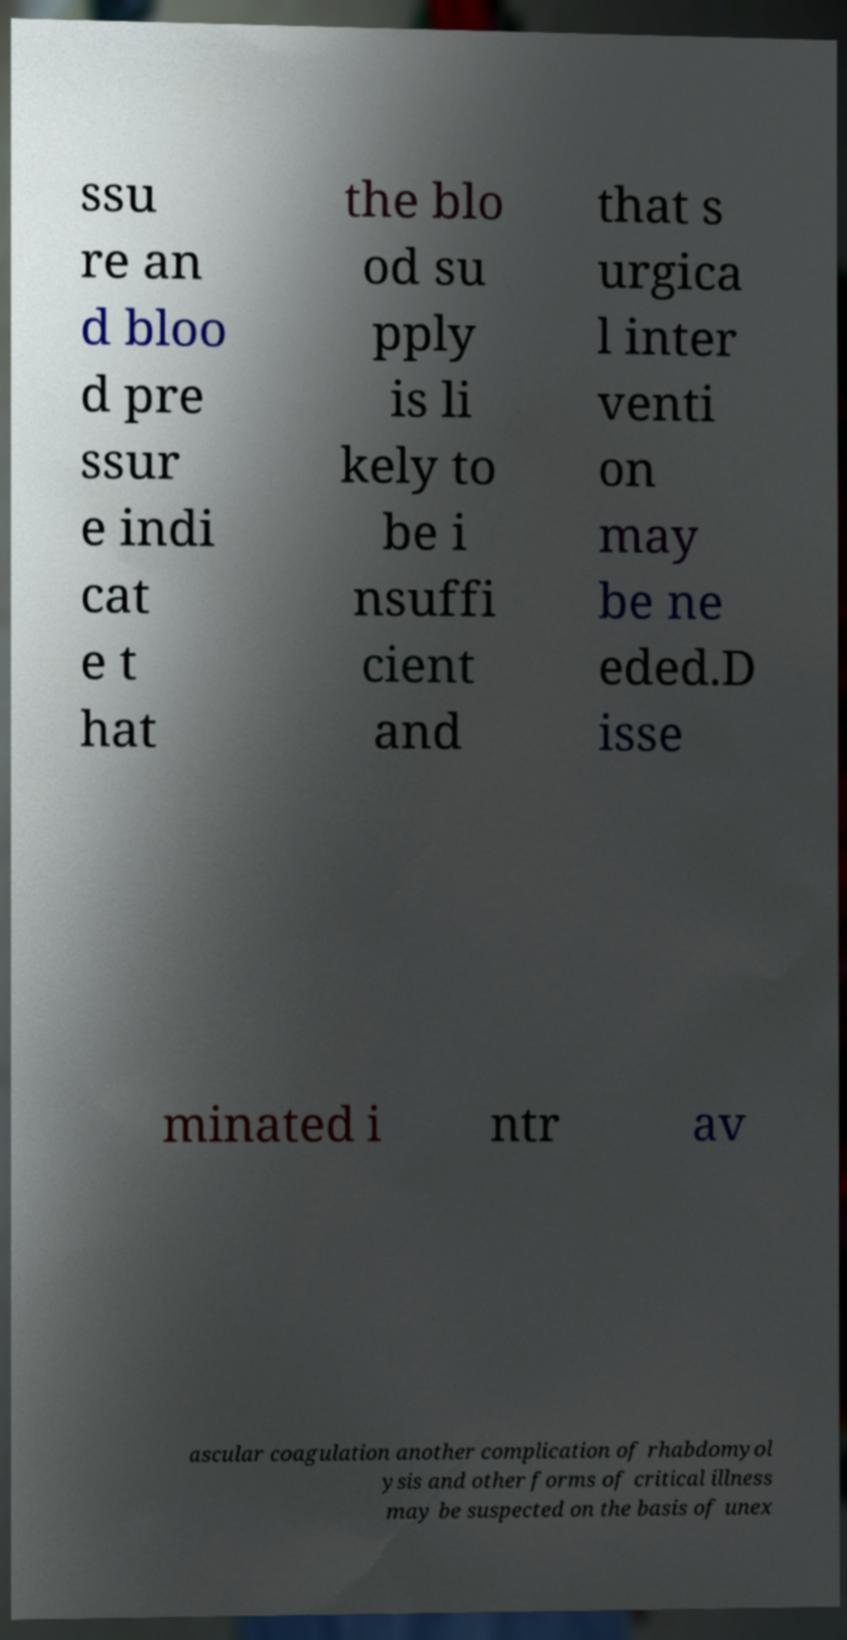Could you extract and type out the text from this image? ssu re an d bloo d pre ssur e indi cat e t hat the blo od su pply is li kely to be i nsuffi cient and that s urgica l inter venti on may be ne eded.D isse minated i ntr av ascular coagulation another complication of rhabdomyol ysis and other forms of critical illness may be suspected on the basis of unex 